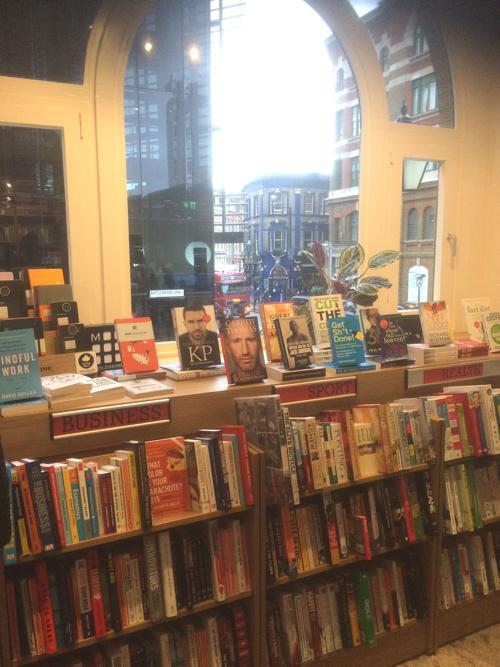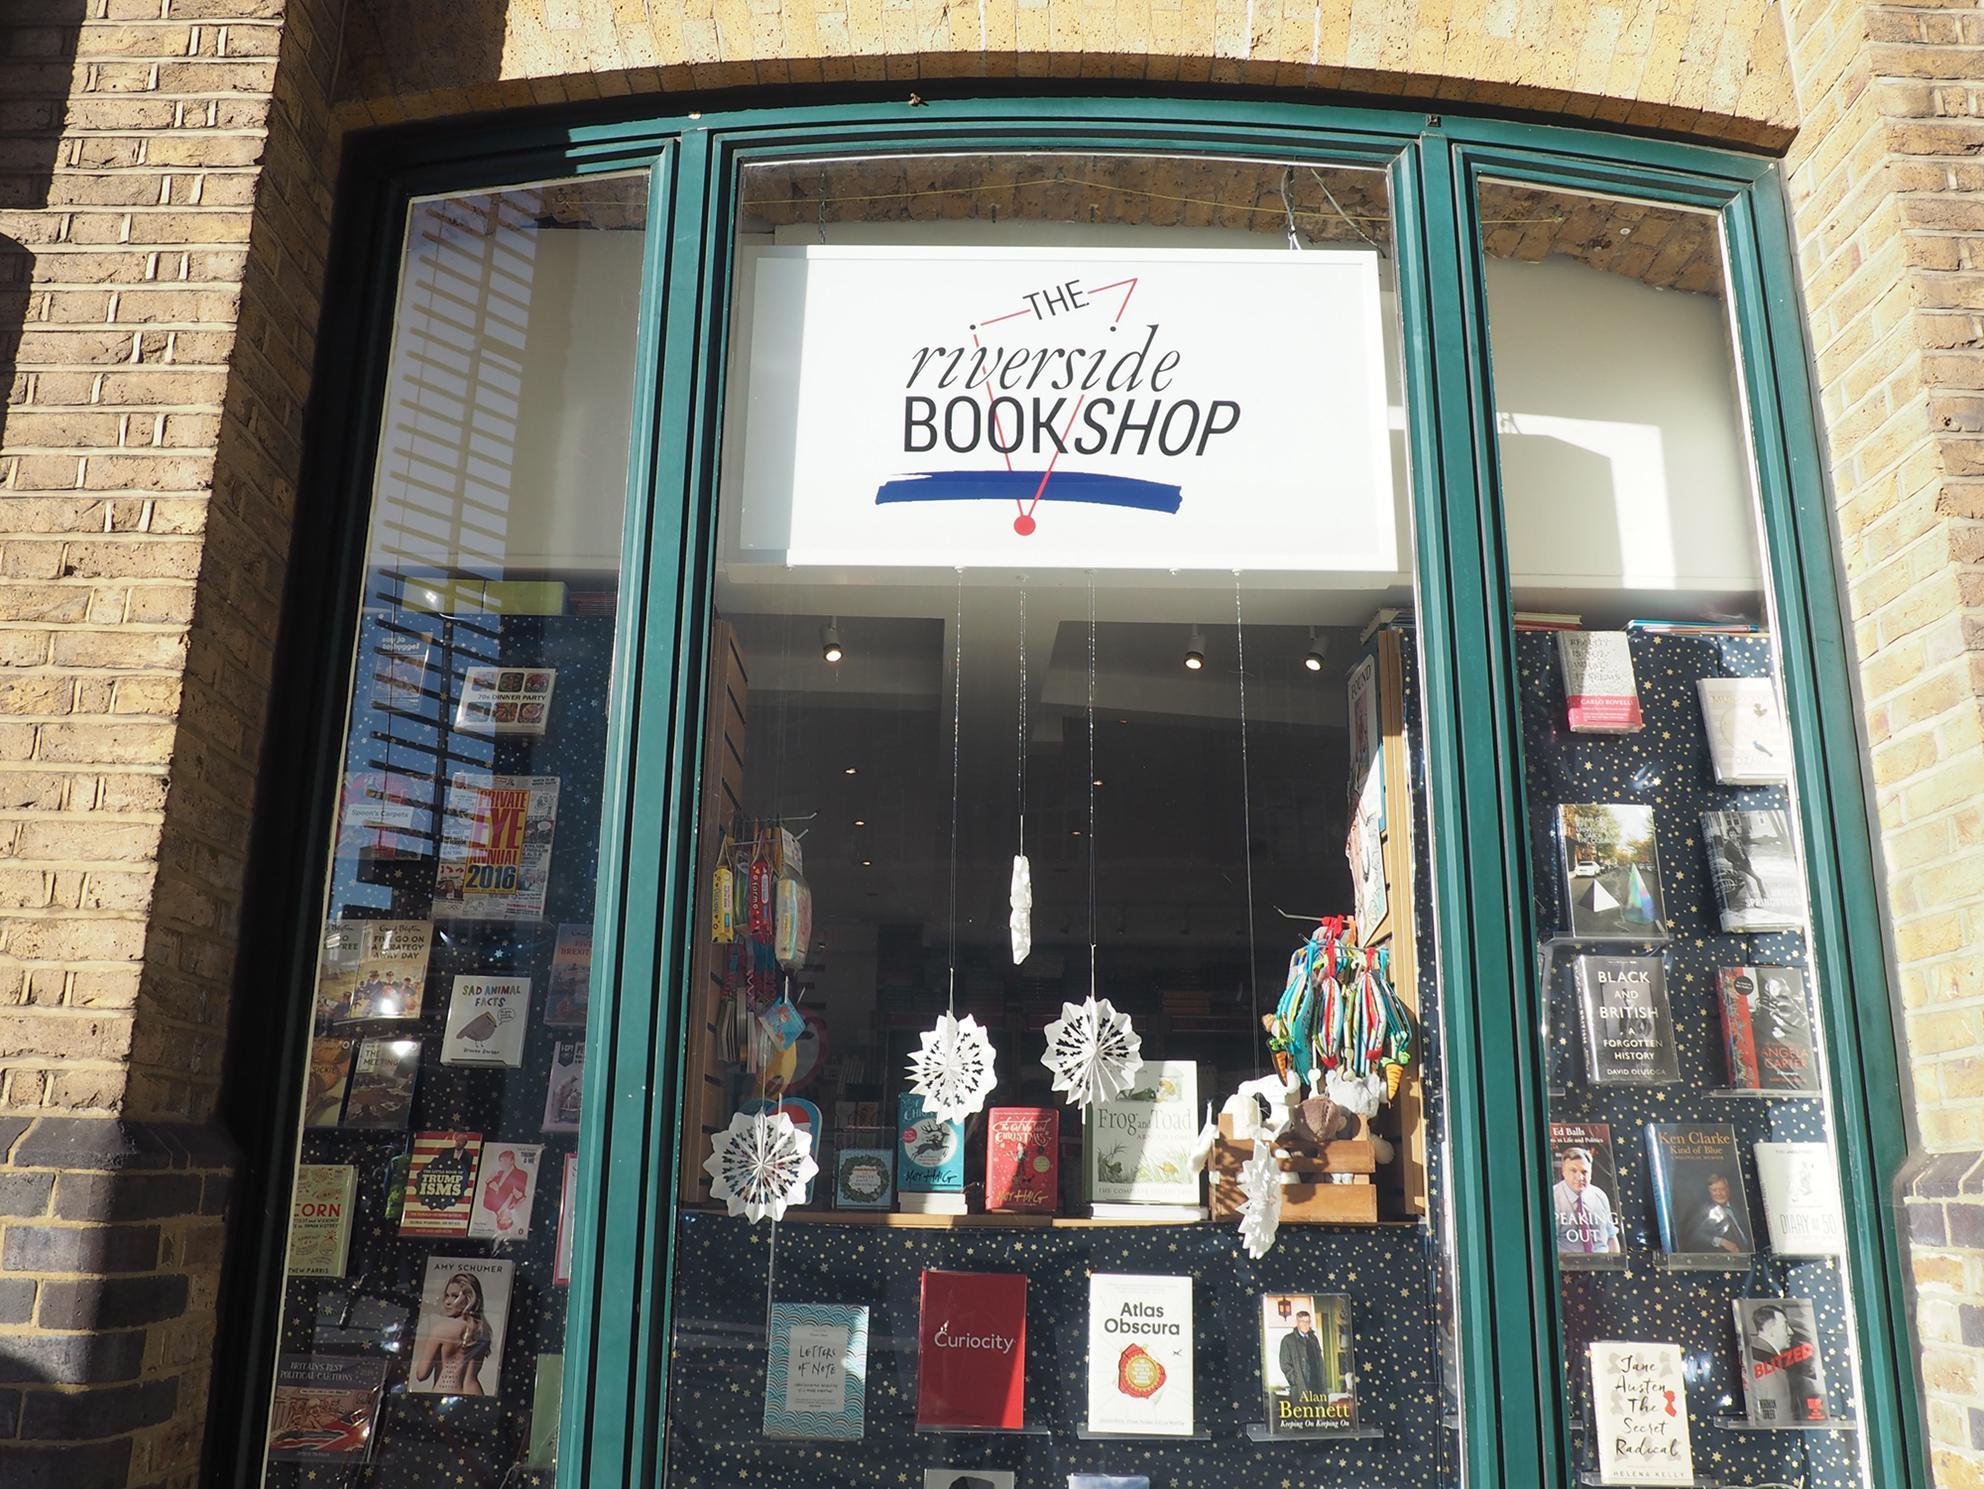The first image is the image on the left, the second image is the image on the right. Analyze the images presented: Is the assertion "A large arch shape is in the center of the left image, surrounded by other window shapes." valid? Answer yes or no. Yes. The first image is the image on the left, the second image is the image on the right. Given the left and right images, does the statement "There are people visible, walking right outside of the building." hold true? Answer yes or no. No. 